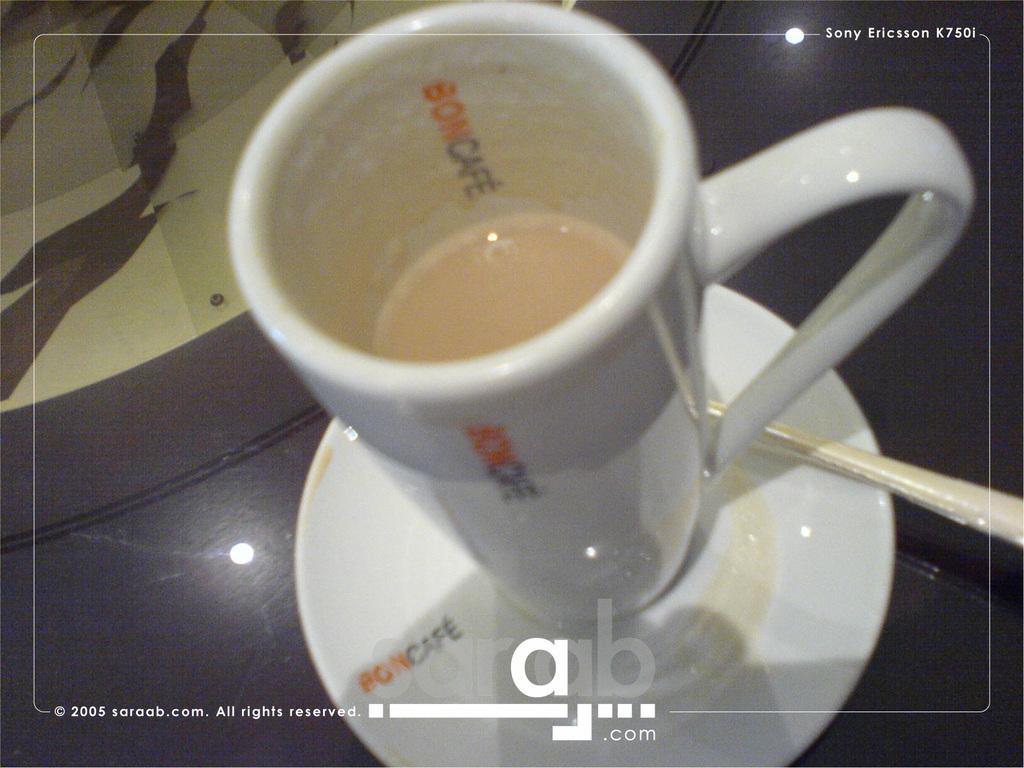Could you give a brief overview of what you see in this image? In this image there is a saucer truncated towards the bottom of the image, there is a spoon truncated towards the right of the image, there is a cup, there is drink inside the cup, there is text, there is a table truncated. 